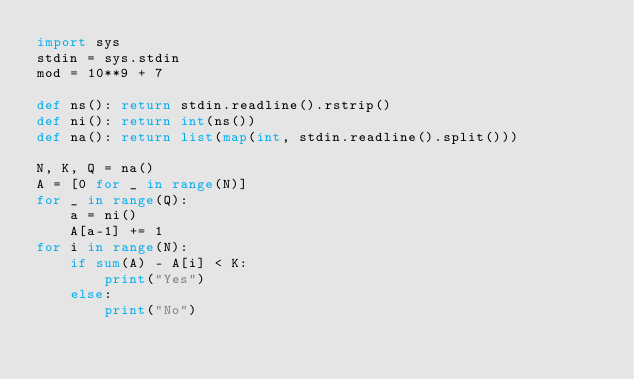Convert code to text. <code><loc_0><loc_0><loc_500><loc_500><_Python_>import sys
stdin = sys.stdin
mod = 10**9 + 7

def ns(): return stdin.readline().rstrip()
def ni(): return int(ns())
def na(): return list(map(int, stdin.readline().split()))

N, K, Q = na()
A = [0 for _ in range(N)]
for _ in range(Q):
    a = ni()
    A[a-1] += 1
for i in range(N):
    if sum(A) - A[i] < K:
        print("Yes")
    else:
        print("No")</code> 